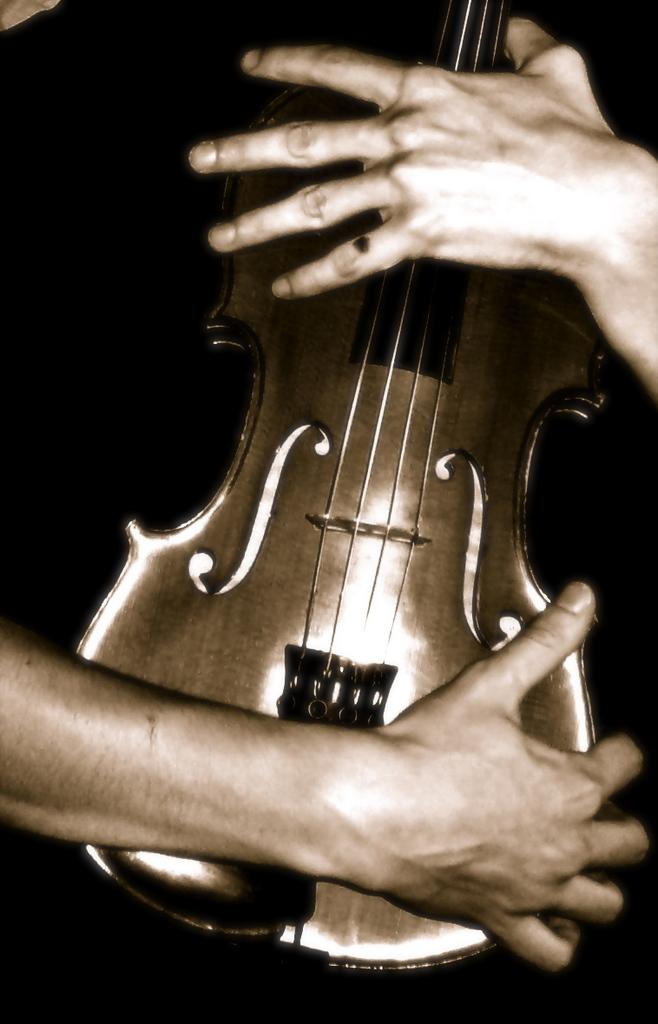What is the main object in the image? There is a guitar in the image. Who is holding the guitar? The guitar is being held by a person's hand. Can you describe the lighting in the image? The image is dark. How many cakes are being carried by the fireman in the image? There is no fireman or cakes present in the image. 